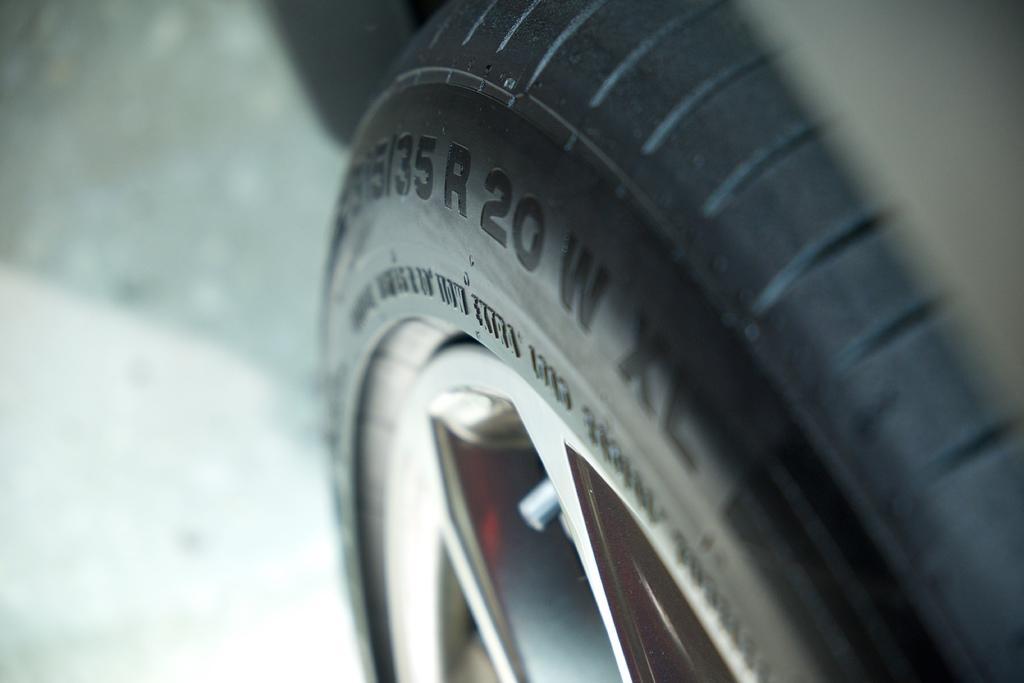Can you describe this image briefly? In this picture we can see a tyre and a wheel, there's a blurry background, we can see numbers on the tyre. 